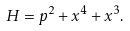Convert formula to latex. <formula><loc_0><loc_0><loc_500><loc_500>H = p ^ { 2 } + x ^ { 4 } + x ^ { 3 } .</formula> 